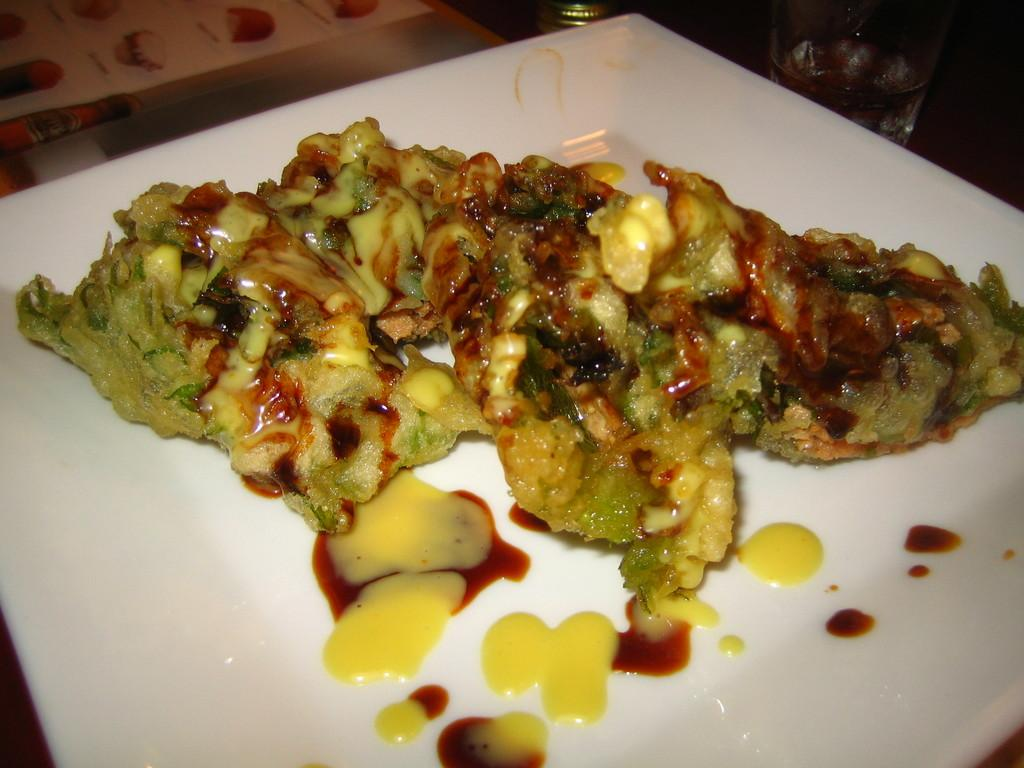What is on the plate that is visible in the image? There is food on a white plate in the image. What type of paint is being used by the kittens in the image? There are no kittens present in the image, and therefore no paint or painting activity can be observed. 